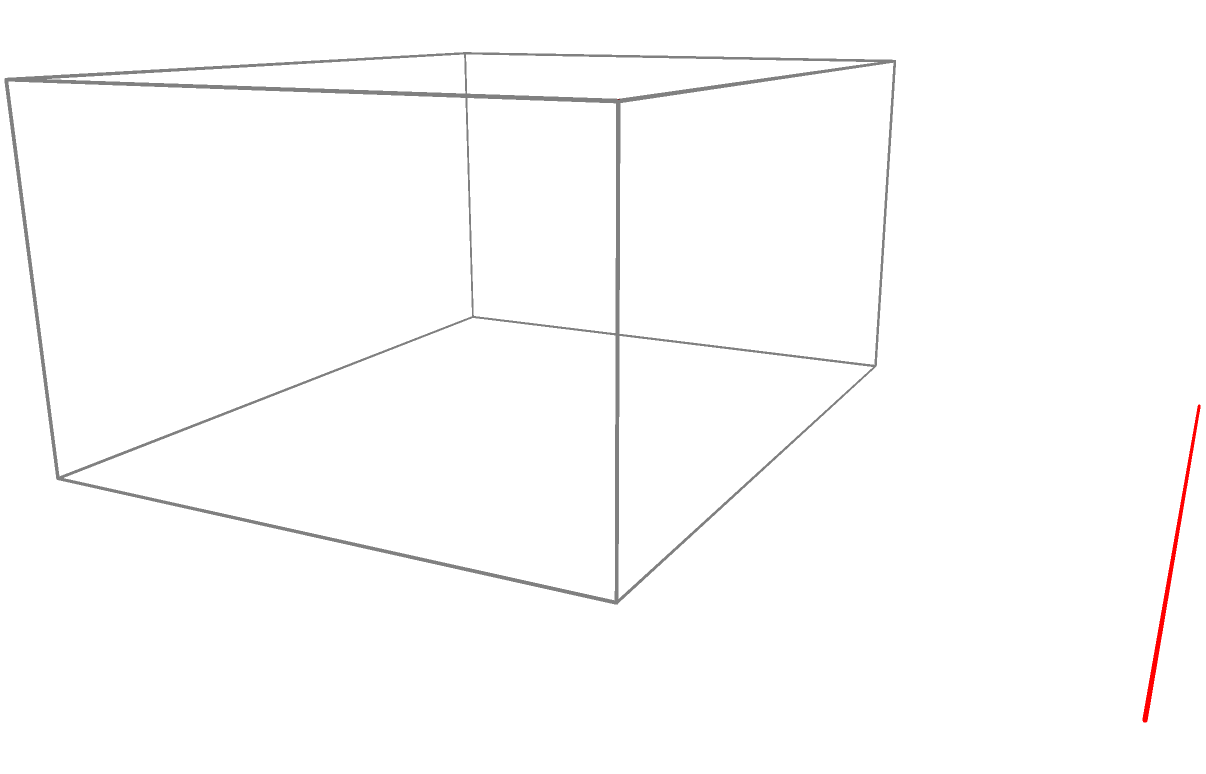As a ballet dancer familiar with theater layouts, which colored dot represents the perspective from which this image of a ballet theater was created? To determine the correct perspective, let's analyze the image step-by-step:

1. The stage is represented by the gray box, with the front of the stage facing the viewer.
2. The brown plane at the top represents the audience seating area, which slopes upward from the stage.
3. The red plane at the back represents the curtains.
4. A black silhouette of a ballet dancer is visible on the stage.

Now, let's consider each viewpoint:

1. Red dot (15,4,2.5): This would be a side view, which doesn't match our perspective.
2. Blue dot (5,12,2.5): This would be a view from behind the curtain, which we don't see in the image.
3. Green dot (5,4,7.5): This represents a view from above and slightly in front of the stage, which matches our perspective.

The image shows a view from above and slightly in front of the stage, allowing us to see the stage floor, the sloping audience seating, and the back curtain. This perspective is consistent with the position of the green dot.
Answer: Green dot 